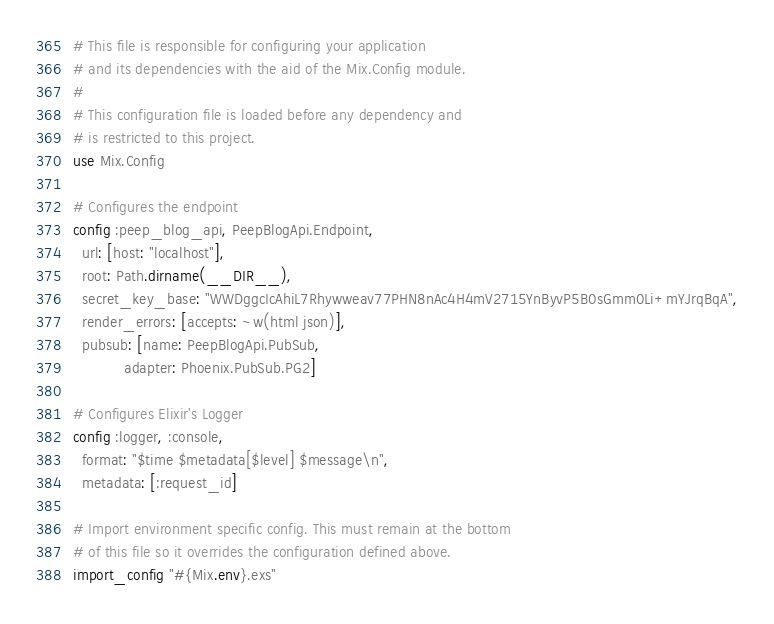<code> <loc_0><loc_0><loc_500><loc_500><_Elixir_># This file is responsible for configuring your application
# and its dependencies with the aid of the Mix.Config module.
#
# This configuration file is loaded before any dependency and
# is restricted to this project.
use Mix.Config

# Configures the endpoint
config :peep_blog_api, PeepBlogApi.Endpoint,
  url: [host: "localhost"],
  root: Path.dirname(__DIR__),
  secret_key_base: "WWDggcIcAhiL7Rhywweav77PHN8nAc4H4mV2715YnByvP5B0sGmm0Li+mYJrqBqA",
  render_errors: [accepts: ~w(html json)],
  pubsub: [name: PeepBlogApi.PubSub,
           adapter: Phoenix.PubSub.PG2]

# Configures Elixir's Logger
config :logger, :console,
  format: "$time $metadata[$level] $message\n",
  metadata: [:request_id]

# Import environment specific config. This must remain at the bottom
# of this file so it overrides the configuration defined above.
import_config "#{Mix.env}.exs"
</code> 